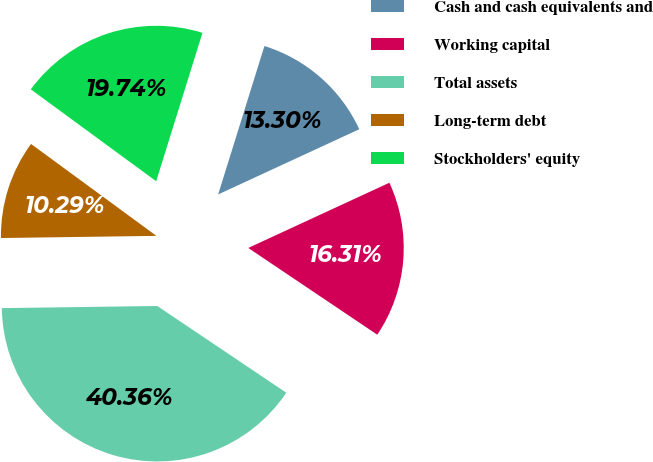<chart> <loc_0><loc_0><loc_500><loc_500><pie_chart><fcel>Cash and cash equivalents and<fcel>Working capital<fcel>Total assets<fcel>Long-term debt<fcel>Stockholders' equity<nl><fcel>13.3%<fcel>16.31%<fcel>40.36%<fcel>10.29%<fcel>19.74%<nl></chart> 